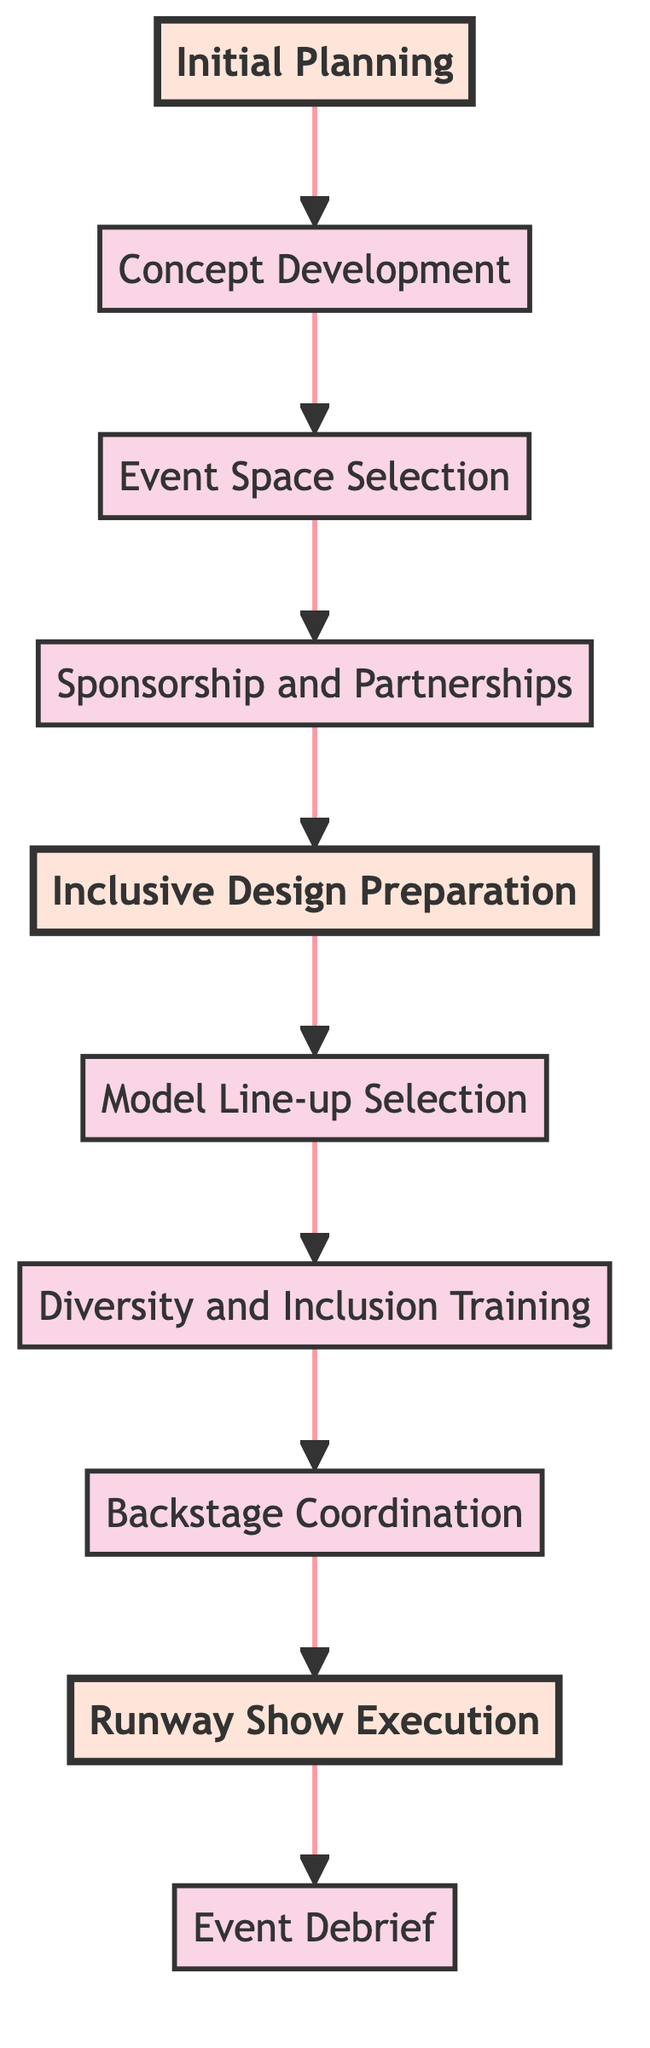What is the last step before the event debrief? The final step before the event debrief is the runway show execution, as indicated by the flow of the diagram leading to the event debrief.
Answer: Runway Show Execution How many nodes are in the flowchart? The flowchart contains ten nodes representing different steps in organizing the fashion show.
Answer: Ten What is the emphasized node immediately following the initial planning? The node that comes immediately after the initial planning is concept development, which is emphasized as part of the main planning phases.
Answer: Concept Development What is the primary focus of the diversity and inclusion training? The primary focus of the training is on diversity, equity, and inclusion, specifically emphasizing the importance of LGBTQ+ representation.
Answer: LGBTQ+ representation Which step involves the selection of models? The step that involves the selection of models is the model line-up selection, focusing on diversity and inclusivity.
Answer: Model Line-up Selection What is the flow of the diagram between the inclusiveness training and the runway show execution? The flow of the diagram shows that after diversity and inclusion training, the next step is backstage coordination, which then leads to runway show execution.
Answer: Backstage Coordination Which node directly precedes the inclusive design preparation? The node that directly precedes inclusive design preparation is sponsorship and partnerships, indicating the need for external support before design.
Answer: Sponsorship and Partnerships What are the emphasized nodes in the flowchart? The emphasized nodes in the flowchart are initial planning, inclusive design preparation, and runway show execution, highlighting critical stages in the process.
Answer: Initial Planning, Inclusive Design Preparation, Runway Show Execution What indicates that initial planning is a critical step in this flowchart? Initial planning is marked as an emphasized node, suggesting its importance as the starting point for the entire process.
Answer: Emphasized Node 